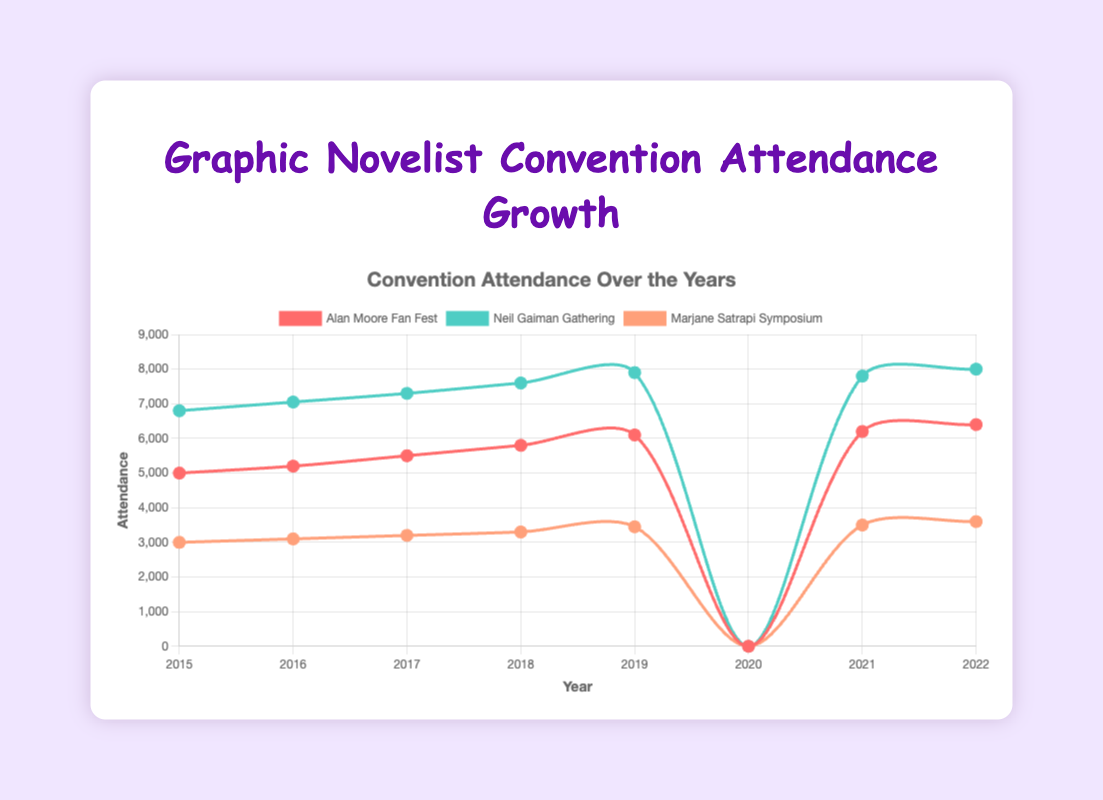What is the trend in attendance for the Alan Moore Fan Fest from 2015 to 2022? The data points show an increasing trend in attendance for Alan Moore Fan Fest from 5000 in 2015 to 6400 in 2022, with a drop to 0 in 2020 due to cancellation.
Answer: Increasing How did the attendance for Neil Gaiman Gathering change from 2015 to 2022? Neil Gaiman Gathering showed a consistently increasing trend from 6800 in 2015 to 8000 in 2022, except for 2020 when it was canceled.
Answer: Increased Which convention had the highest attendance in 2022? In 2022, the Neil Gaiman Gathering had the highest attendance with 8000 attendees.
Answer: Neil Gaiman Gathering What was the total attendance for all three conventions in 2017? Alan Moore Fan Fest had 5500, Neil Gaiman Gathering had 7300, and Marjane Satrapi Symposium had 3200 attendees. Summing these gives 5500 + 7300 + 3200 = 16000.
Answer: 16000 How many more people attended Neil Gaiman Gathering compared to Marjane Satrapi Symposium in 2022? In 2022, the Neil Gaiman Gathering had 8000 attendees and the Marjane Satrapi Symposium had 3600 attendees. 8000 - 3600 = 4400.
Answer: 4400 What is the average attendance across all three conventions per year from 2015 to 2019? For each year, sum the attendances for the three conventions and divide by 3, then find the average across the 5 years. 2015: (5000 + 6800 + 3000)/3, 2016: (5200 + 7050 + 3100)/3, 2017: (5500 + 7300 + 3200)/3, 2018: (5800 + 7600 + 3300)/3, 2019: (6100 + 7900 + 3450)/3. Average these results. = (14600/3 + 15350/3 + 16000/3 + 16700/3 + 17450/3)/5 = 51200/15 = 3413.33
Answer: 3413.33 Which year saw the highest attendance for Marjane Satrapi Symposium? Marjane Satrapi Symposium saw its highest attendance in 2022 with 3600 attendees.
Answer: 2022 Compared to 2015, how much did the attendance for Alan Moore Fan Fest increase by 2022? In 2015, attendance was 5000 and in 2022, it was 6400. The increase is 6400 - 5000 = 1400.
Answer: 1400 What happened to the attendance trends for all conventions in 2020? In 2020, the attendance for all conventions dropped to 0 due to cancellations caused by COVID-19.
Answer: Dropped to 0 How did the attendance trends of Alan Moore Fan Fest compare to Neil Gaiman Gathering from 2015 to 2022? Both showed increasing trends with a cancellation in 2020. However, Neil Gaiman Gathering had consistently higher attendance numbers compared to Alan Moore Fan Fest each year.
Answer: Neil Gaiman Gathering had higher attendance 